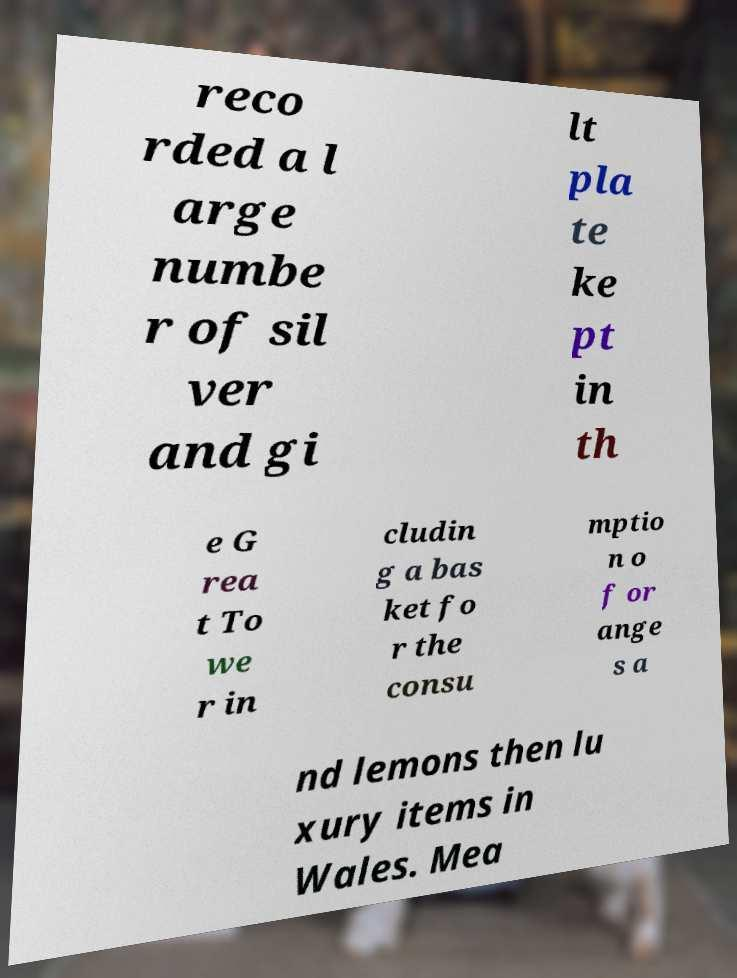Could you extract and type out the text from this image? reco rded a l arge numbe r of sil ver and gi lt pla te ke pt in th e G rea t To we r in cludin g a bas ket fo r the consu mptio n o f or ange s a nd lemons then lu xury items in Wales. Mea 